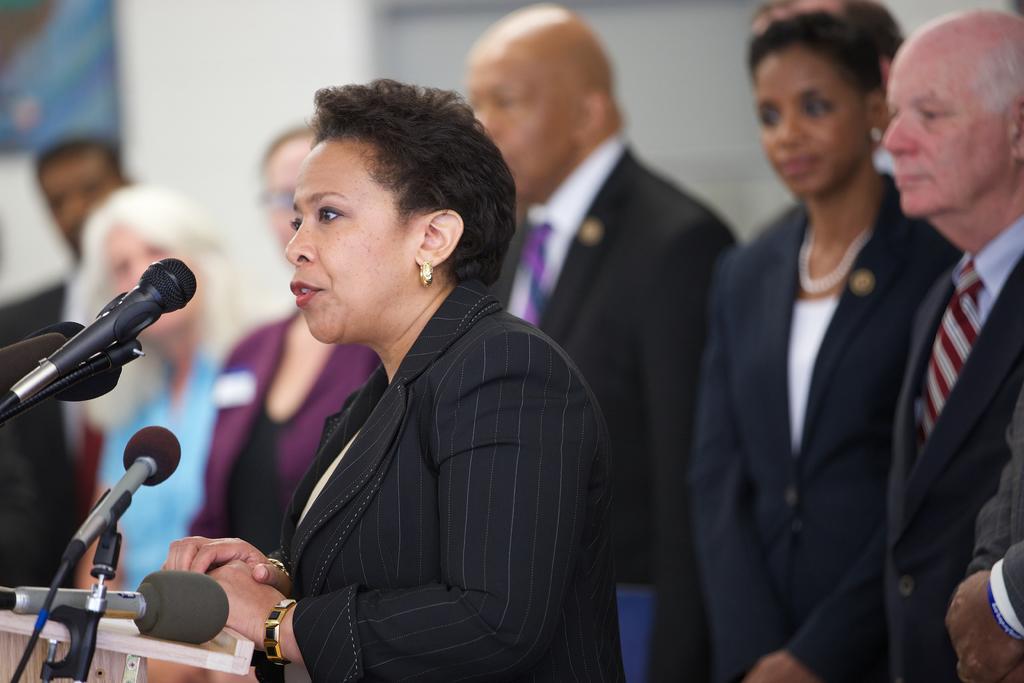Please provide a concise description of this image. In the image we can see a woman standing, wearing clothes, bracelet and it looks like she is talking. Here we can see the microphones and behind her there are many other people standing, wearing clothes and the background is slightly blurred. 